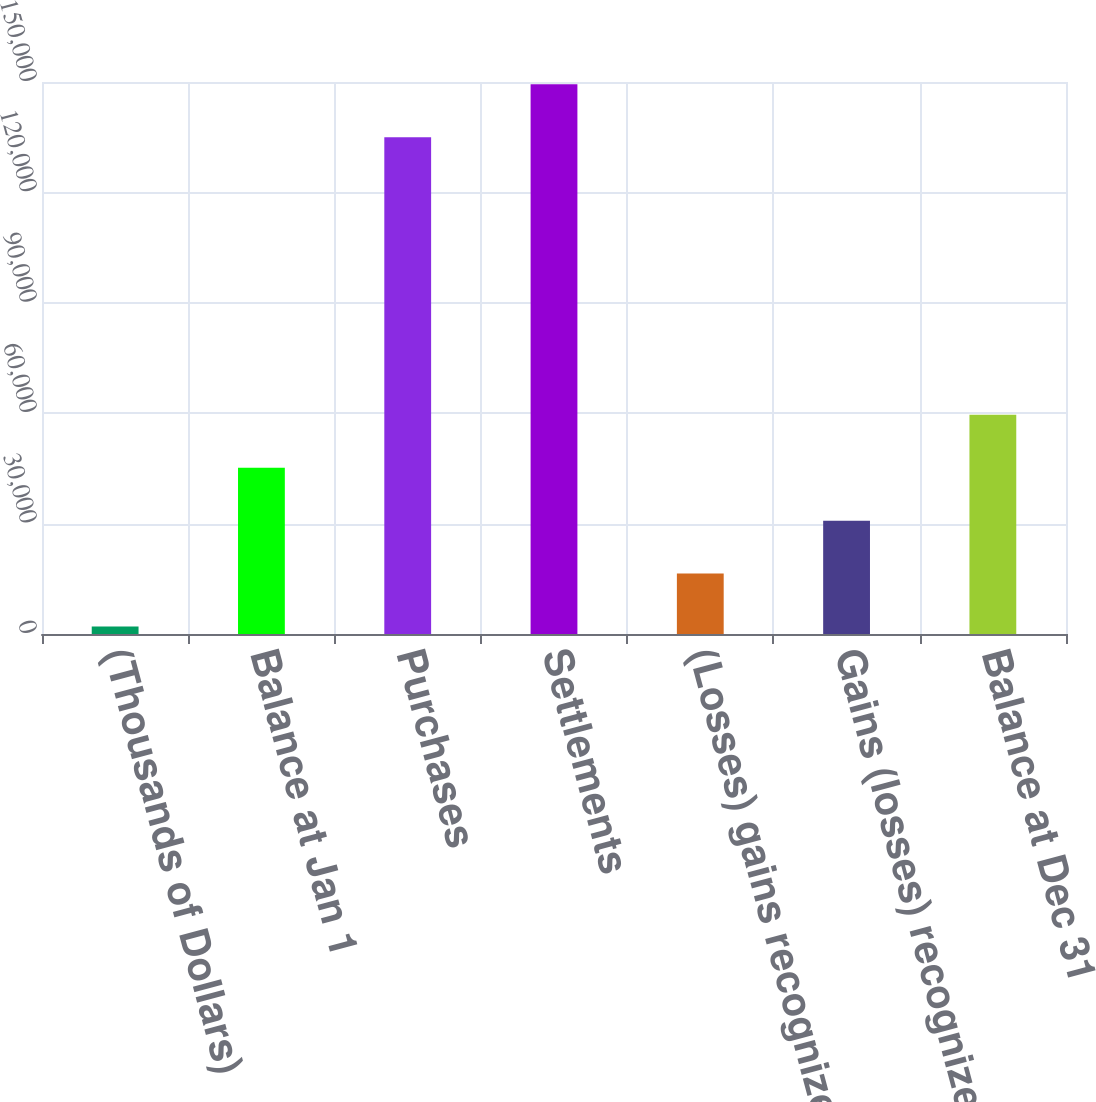<chart> <loc_0><loc_0><loc_500><loc_500><bar_chart><fcel>(Thousands of Dollars)<fcel>Balance at Jan 1<fcel>Purchases<fcel>Settlements<fcel>(Losses) gains recognized in<fcel>Gains (losses) recognized as<fcel>Balance at Dec 31<nl><fcel>2014<fcel>45202<fcel>135008<fcel>149404<fcel>16410<fcel>30806<fcel>59598<nl></chart> 